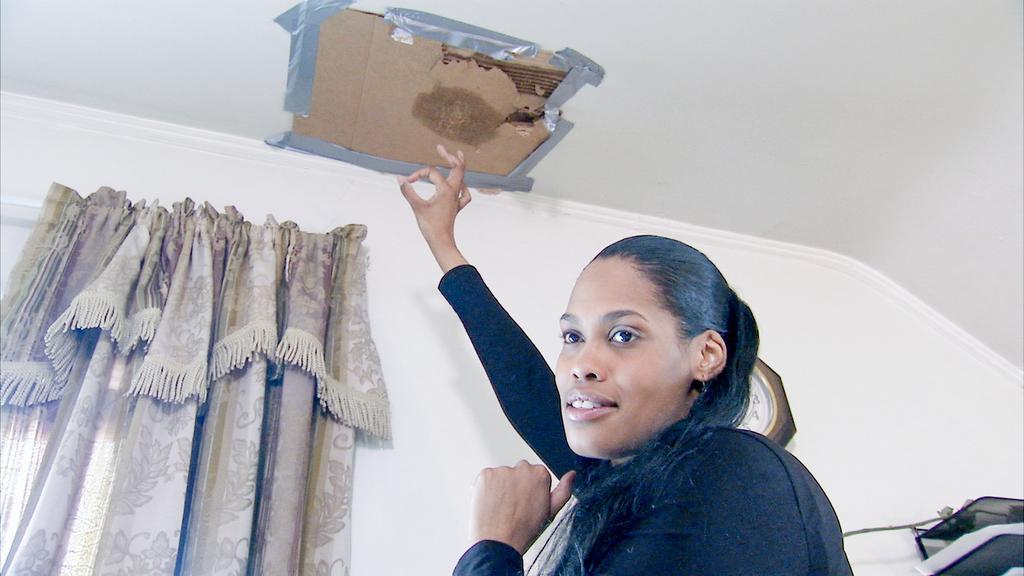How would you summarize this image in a sentence or two? In this image I can see the person wearing the black color dress. To the left I can see the curtains. To the right I can see the black color objects. I can see the cardboard sheet attached to the ceiling. 